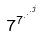Convert formula to latex. <formula><loc_0><loc_0><loc_500><loc_500>7 ^ { 7 ^ { \cdot ^ { \cdot ^ { \cdot ^ { j } } } } }</formula> 